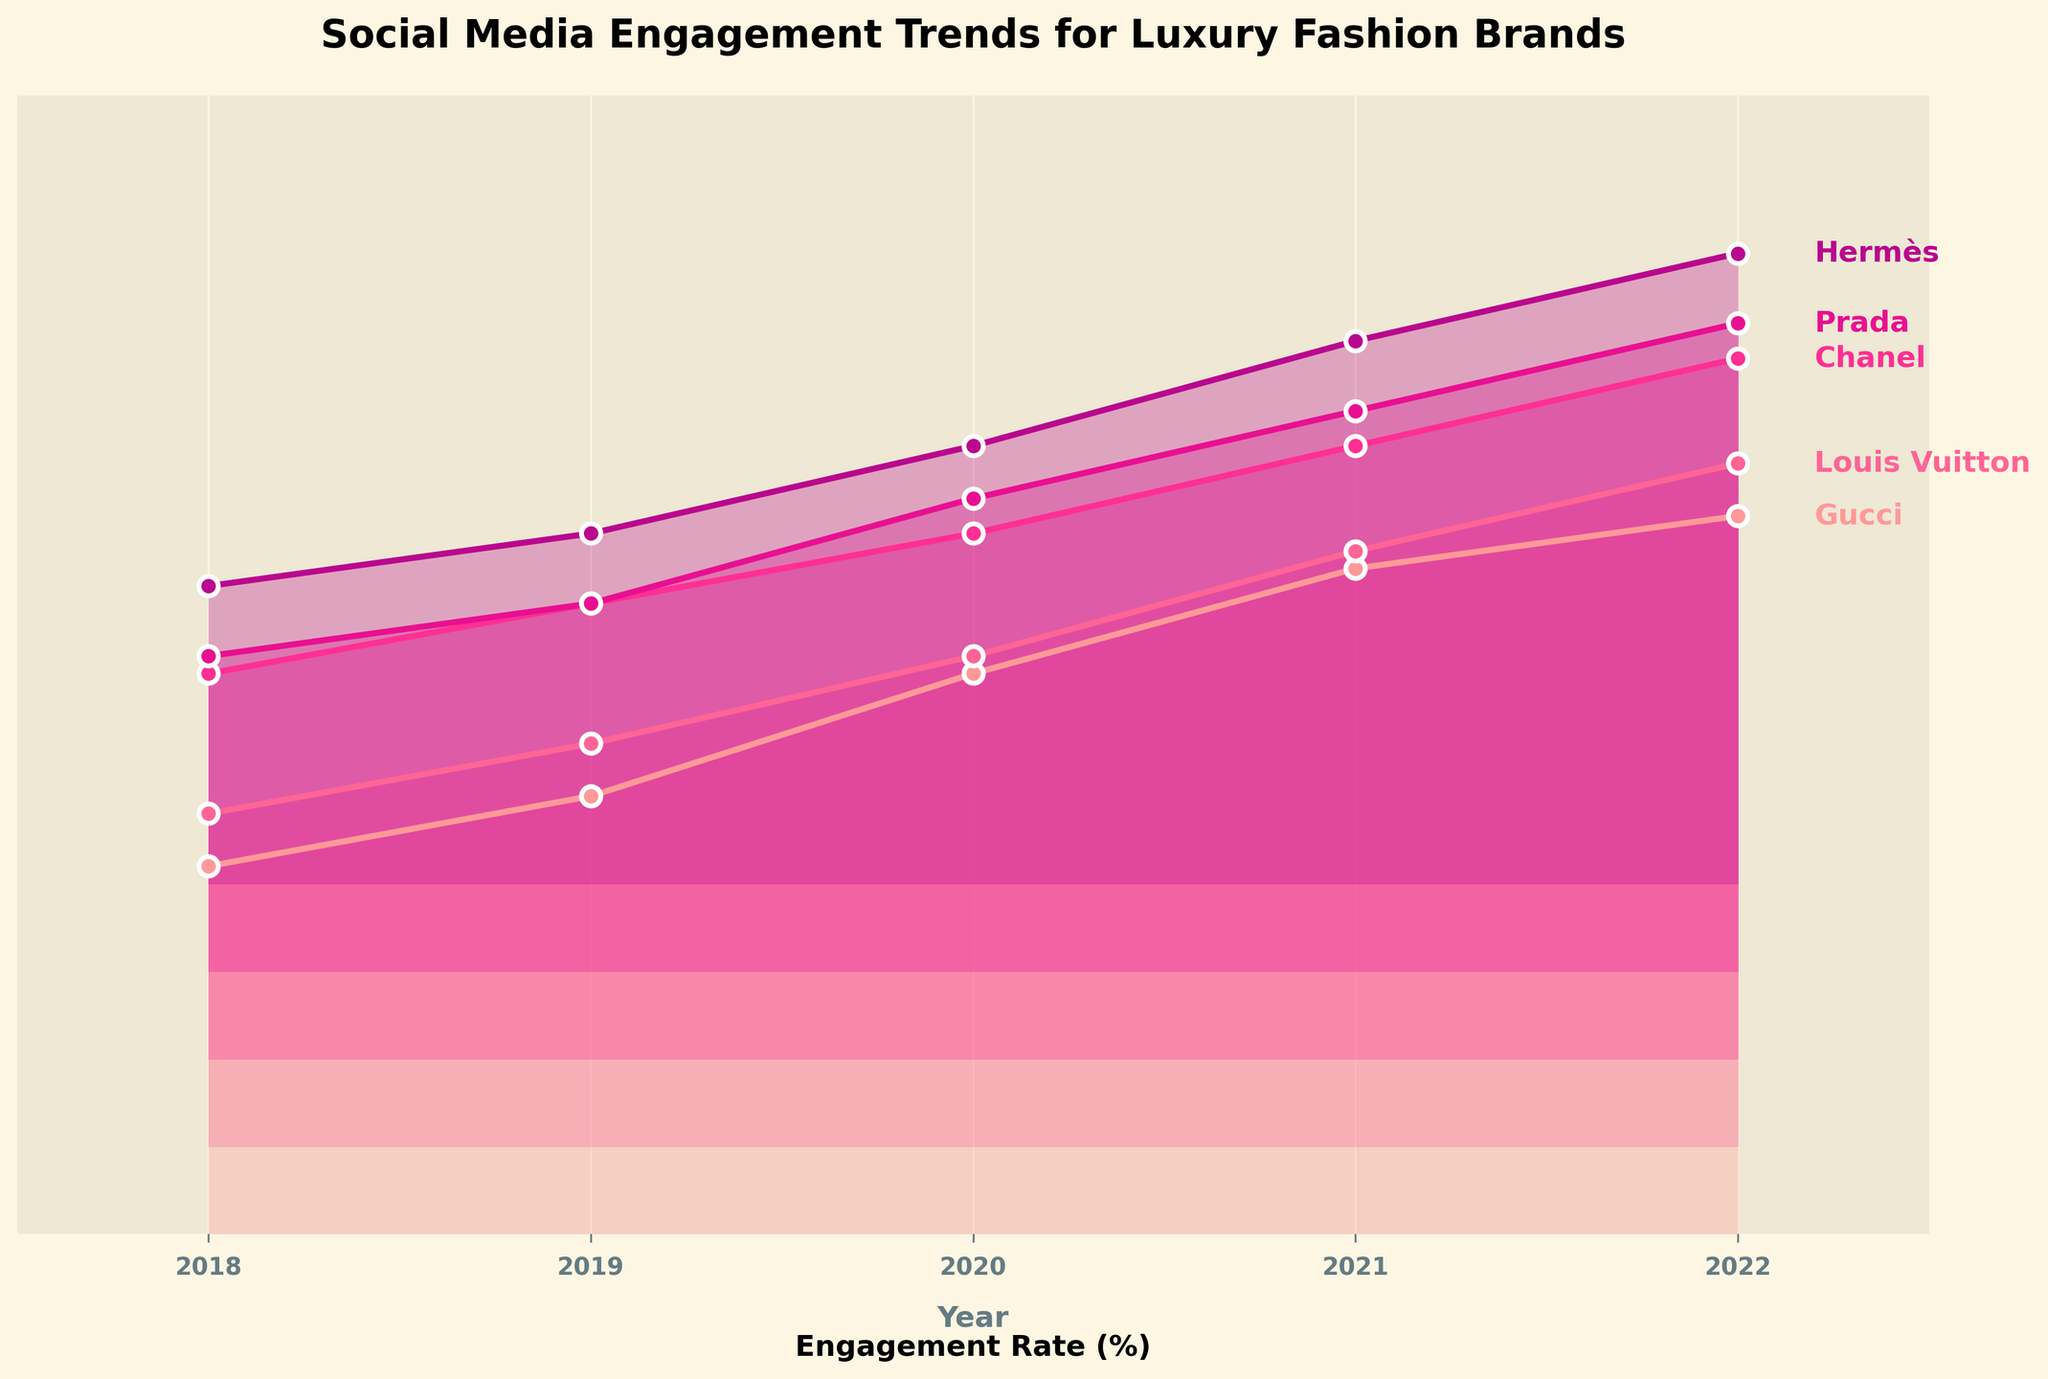Which brand has the highest final engagement rate in 2022? Looking at the rightmost points on the plot, each line ends at a different height for 2022. Chanel reaches the highest point in 2022.
Answer: Chanel Which brand had the lowest engagement rate in 2018? Examining the leftmost points on the plot for the year 2018, Hermès has the lowest engagement rate compared to the other brands.
Answer: Hermès What is the overall trend of engagement rates for Gucci from 2018 to 2022? By following Gucci's line from left to right, you can see it consistently increases from 2018 to 2022.
Answer: Increasing How does the 2021 engagement rate of Louis Vuitton compare to that of Gucci in the same year? Comparing the heights of the lines for Louis Vuitton and Gucci in 2021, Gucci's line is higher, indicating a higher engagement rate.
Answer: Gucci's is higher Which brand showed the greatest increase in engagement rate from 2019 to 2020? Looking at the vertical distance between points from 2019 to 2020 for all brands, Gucci’s increase is the greatest.
Answer: Gucci How many years of data are shown in this plot? The x-axis ticks show years ranging from 2018 to 2022, which is 5 years of data.
Answer: 5 What is the title of the plot? The title is prominently displayed at the top of the plot.
Answer: Social Media Engagement Trends for Luxury Fashion Brands Which brand's engagement rate decreased the most in any given year? Observing each line, none of the brands show a decrease; all are continuously increasing over the years.
Answer: None What was the engagement rate for Prada in 2020? Following Prada's line to the year 2020 on the x-axis reveals the engagement rate.
Answer: 2.7 Are there any brands with overlapping engagement rates at any year? Each brand's engagement rates are vertically separated, and no two brands have identical rates in the same year.
Answer: No 